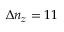<formula> <loc_0><loc_0><loc_500><loc_500>\Delta n _ { z } = 1 1</formula> 